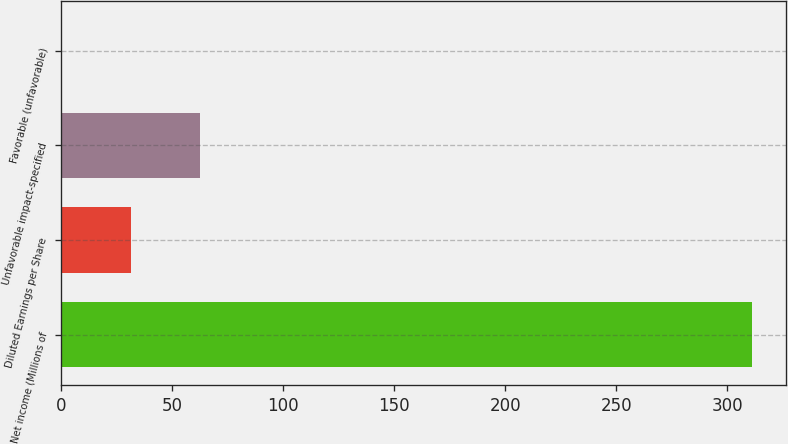<chart> <loc_0><loc_0><loc_500><loc_500><bar_chart><fcel>Net income (Millions of<fcel>Diluted Earnings per Share<fcel>Unfavorable impact-specified<fcel>Favorable (unfavorable)<nl><fcel>311<fcel>31.39<fcel>62.46<fcel>0.32<nl></chart> 